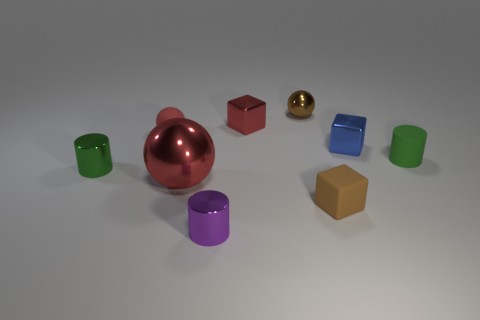What number of tiny objects are brown balls or purple rubber balls?
Make the answer very short. 1. There is a green object that is to the left of the small brown shiny sphere; is its size the same as the red metallic object that is in front of the blue block?
Provide a succinct answer. No. What is the size of the green rubber thing that is the same shape as the purple object?
Your answer should be very brief. Small. Is the number of small purple metal cylinders that are right of the tiny metallic ball greater than the number of rubber things that are behind the small red rubber sphere?
Ensure brevity in your answer.  No. What is the material of the tiny thing that is on the right side of the tiny red metallic thing and in front of the big red shiny object?
Ensure brevity in your answer.  Rubber. There is another shiny thing that is the same shape as the tiny purple metal thing; what color is it?
Give a very brief answer. Green. What is the size of the purple cylinder?
Make the answer very short. Small. What is the color of the block in front of the cylinder that is right of the tiny brown matte block?
Your answer should be compact. Brown. How many small rubber objects are on the right side of the purple shiny object and behind the matte cube?
Offer a terse response. 1. Is the number of small gray metal objects greater than the number of tiny green metallic objects?
Keep it short and to the point. No. 